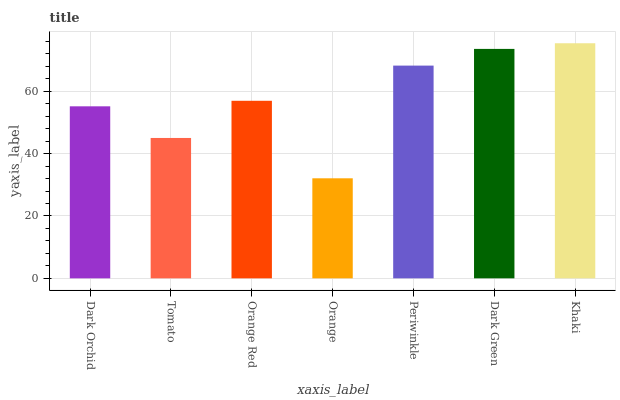Is Orange the minimum?
Answer yes or no. Yes. Is Khaki the maximum?
Answer yes or no. Yes. Is Tomato the minimum?
Answer yes or no. No. Is Tomato the maximum?
Answer yes or no. No. Is Dark Orchid greater than Tomato?
Answer yes or no. Yes. Is Tomato less than Dark Orchid?
Answer yes or no. Yes. Is Tomato greater than Dark Orchid?
Answer yes or no. No. Is Dark Orchid less than Tomato?
Answer yes or no. No. Is Orange Red the high median?
Answer yes or no. Yes. Is Orange Red the low median?
Answer yes or no. Yes. Is Khaki the high median?
Answer yes or no. No. Is Orange the low median?
Answer yes or no. No. 